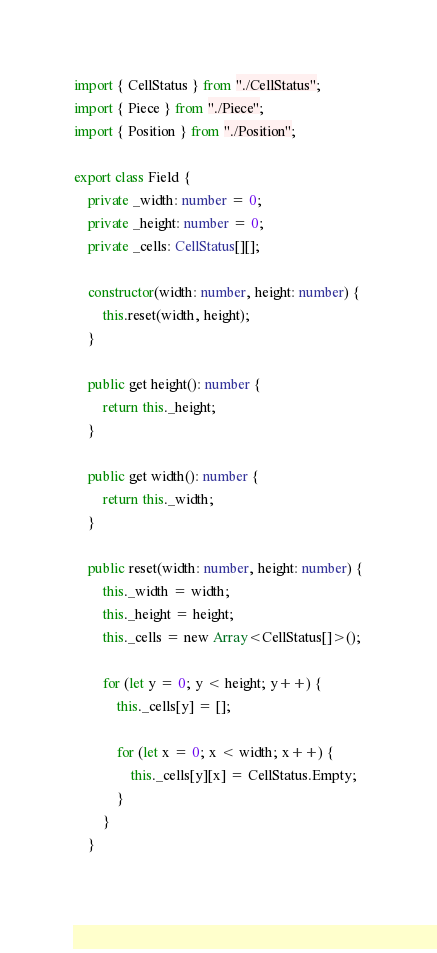<code> <loc_0><loc_0><loc_500><loc_500><_TypeScript_>import { CellStatus } from "./CellStatus";
import { Piece } from "./Piece";
import { Position } from "./Position";

export class Field {
	private _width: number = 0;
	private _height: number = 0;
	private _cells: CellStatus[][];
	
	constructor(width: number, height: number) {
		this.reset(width, height);
	}
	
	public get height(): number {
		return this._height;
	}
	
	public get width(): number {
		return this._width;
	}
	
	public reset(width: number, height: number) {
		this._width = width;
		this._height = height;
		this._cells = new Array<CellStatus[]>();
        
        for (let y = 0; y < height; y++) {
            this._cells[y] = [];
            
            for (let x = 0; x < width; x++) {
                this._cells[y][x] = CellStatus.Empty;
            }
        }
	}
	</code> 